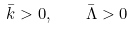<formula> <loc_0><loc_0><loc_500><loc_500>\bar { k } > 0 , \quad \bar { \Lambda } > 0</formula> 